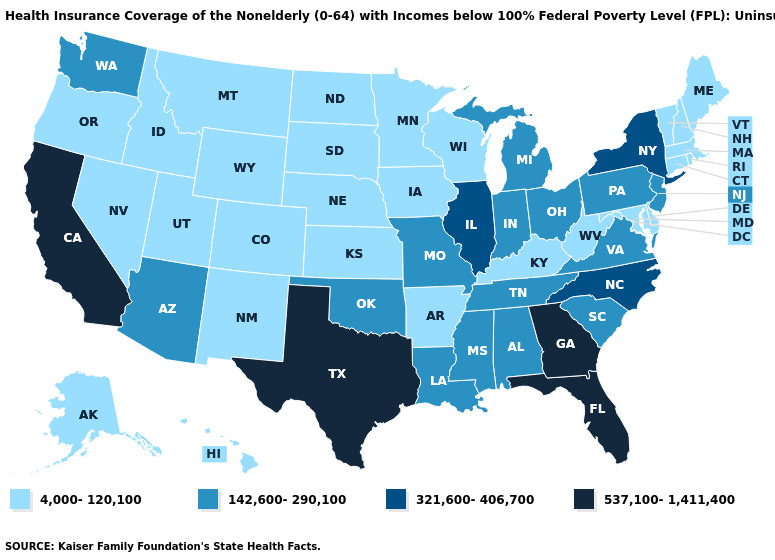Which states have the lowest value in the USA?
Quick response, please. Alaska, Arkansas, Colorado, Connecticut, Delaware, Hawaii, Idaho, Iowa, Kansas, Kentucky, Maine, Maryland, Massachusetts, Minnesota, Montana, Nebraska, Nevada, New Hampshire, New Mexico, North Dakota, Oregon, Rhode Island, South Dakota, Utah, Vermont, West Virginia, Wisconsin, Wyoming. Does Utah have a lower value than New Mexico?
Answer briefly. No. Name the states that have a value in the range 321,600-406,700?
Answer briefly. Illinois, New York, North Carolina. Does Georgia have the highest value in the USA?
Concise answer only. Yes. Name the states that have a value in the range 142,600-290,100?
Write a very short answer. Alabama, Arizona, Indiana, Louisiana, Michigan, Mississippi, Missouri, New Jersey, Ohio, Oklahoma, Pennsylvania, South Carolina, Tennessee, Virginia, Washington. What is the highest value in the West ?
Give a very brief answer. 537,100-1,411,400. How many symbols are there in the legend?
Short answer required. 4. What is the highest value in states that border New York?
Give a very brief answer. 142,600-290,100. Which states have the highest value in the USA?
Write a very short answer. California, Florida, Georgia, Texas. Does Delaware have the lowest value in the USA?
Give a very brief answer. Yes. What is the highest value in states that border Washington?
Concise answer only. 4,000-120,100. Does the map have missing data?
Be succinct. No. Does the first symbol in the legend represent the smallest category?
Write a very short answer. Yes. What is the highest value in the West ?
Concise answer only. 537,100-1,411,400. 